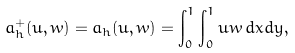Convert formula to latex. <formula><loc_0><loc_0><loc_500><loc_500>a _ { h } ^ { + } ( u , w ) = a _ { h } ( u , w ) = \int _ { 0 } ^ { 1 } \int _ { 0 } ^ { 1 } u w \, d x d y ,</formula> 